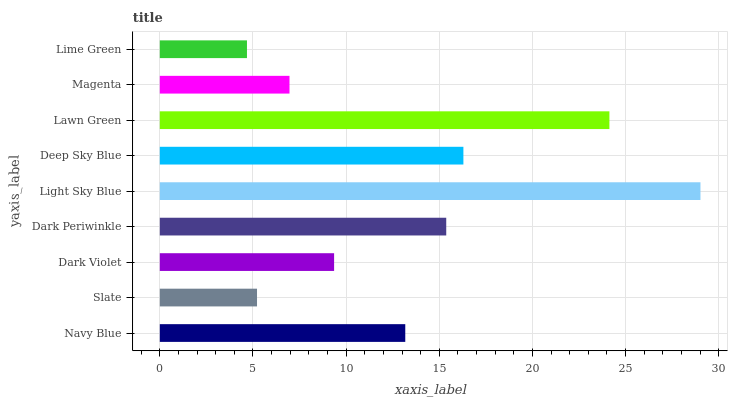Is Lime Green the minimum?
Answer yes or no. Yes. Is Light Sky Blue the maximum?
Answer yes or no. Yes. Is Slate the minimum?
Answer yes or no. No. Is Slate the maximum?
Answer yes or no. No. Is Navy Blue greater than Slate?
Answer yes or no. Yes. Is Slate less than Navy Blue?
Answer yes or no. Yes. Is Slate greater than Navy Blue?
Answer yes or no. No. Is Navy Blue less than Slate?
Answer yes or no. No. Is Navy Blue the high median?
Answer yes or no. Yes. Is Navy Blue the low median?
Answer yes or no. Yes. Is Magenta the high median?
Answer yes or no. No. Is Dark Periwinkle the low median?
Answer yes or no. No. 